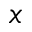<formula> <loc_0><loc_0><loc_500><loc_500>_ { x }</formula> 